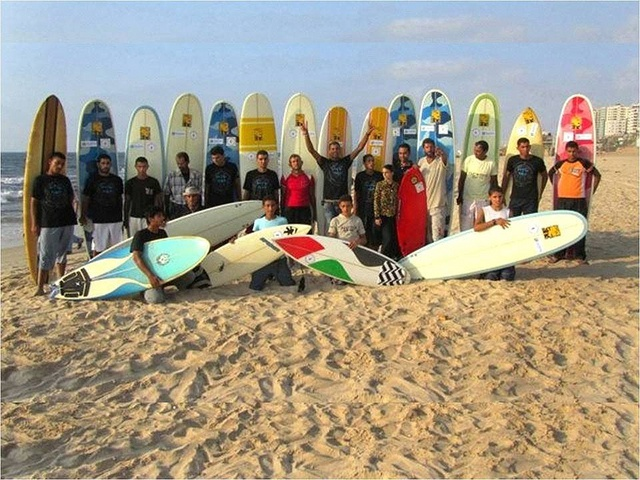Describe the objects in this image and their specific colors. I can see surfboard in white, darkgray, tan, gray, and khaki tones, people in white, black, maroon, gray, and darkgray tones, surfboard in white, lightyellow, darkgray, beige, and tan tones, surfboard in white, aquamarine, lightyellow, khaki, and teal tones, and people in white, black, gray, maroon, and darkgray tones in this image. 